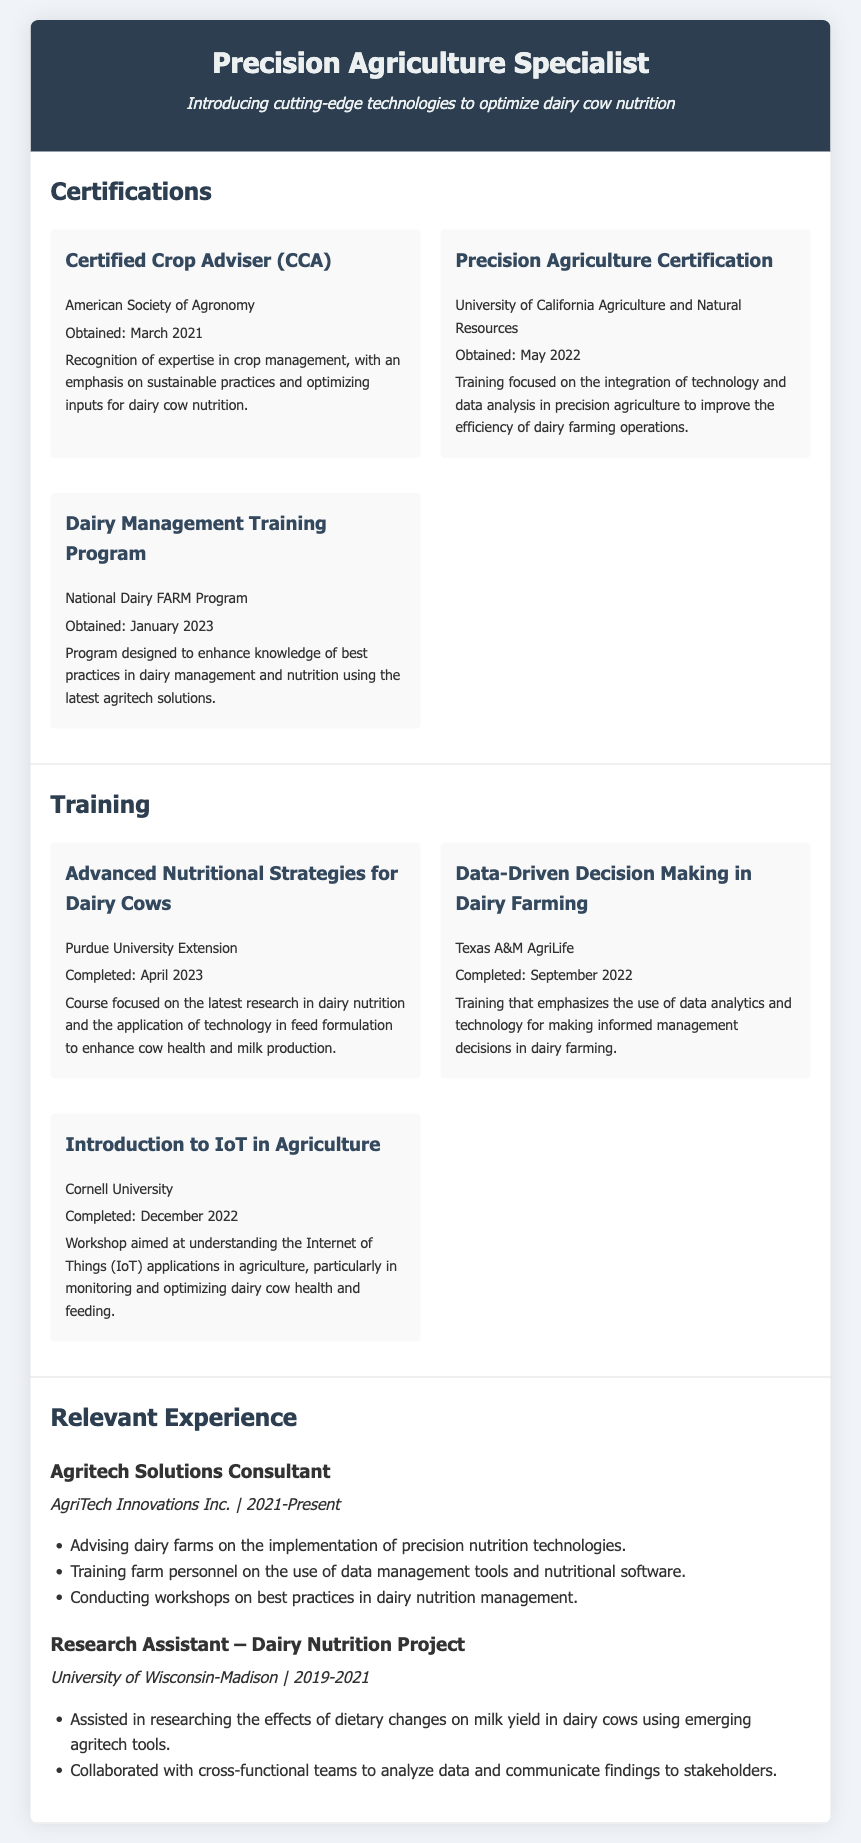what is the title of the resume? The title of the resume is prominently displayed at the top, indicating the individual's profession and specialized area.
Answer: Precision Agriculture Specialist when was the Certified Crop Adviser obtained? The date of obtaining the certification is specified in the document.
Answer: March 2021 which university provided the Precision Agriculture Certification? The document states the institution that offered the certification.
Answer: University of California Agriculture and Natural Resources what is the main focus of the Dairy Management Training Program? The document describes the purpose of the program and its relevance to dairy management.
Answer: Best practices in dairy management and nutrition which course was completed in April 2023? The resume lists various training programs with their completion dates to highlight recent education.
Answer: Advanced Nutritional Strategies for Dairy Cows what training emphasizes data analytics in dairy farming? This aspect of the document highlights specific training that focuses on analytics for decision-making in dairy farming.
Answer: Data-Driven Decision Making in Dairy Farming who is an Agrictech Solutions Consultant? The role within the experience section identifies the current job title held by the individual.
Answer: AgriTech Innovations Inc how many training programs are listed in the resume? The total number of training programs can be counted directly from the document.
Answer: Three 